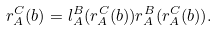<formula> <loc_0><loc_0><loc_500><loc_500>r ^ { C } _ { A } ( b ) = l ^ { B } _ { A } ( r ^ { C } _ { A } ( b ) ) r ^ { B } _ { A } ( r ^ { C } _ { A } ( b ) ) .</formula> 